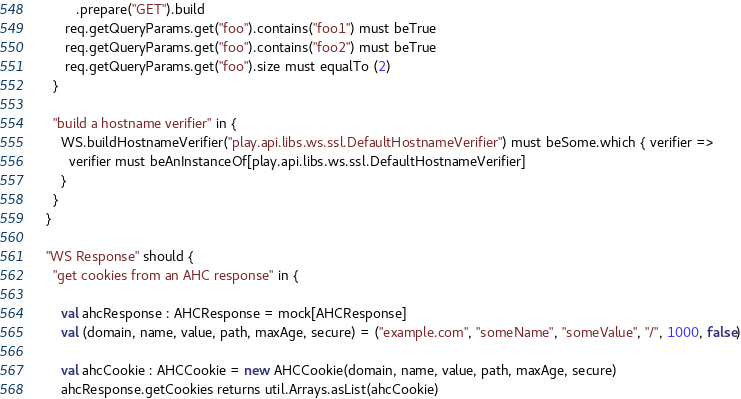<code> <loc_0><loc_0><loc_500><loc_500><_Scala_>          .prepare("GET").build
       req.getQueryParams.get("foo").contains("foo1") must beTrue
       req.getQueryParams.get("foo").contains("foo2") must beTrue
       req.getQueryParams.get("foo").size must equalTo (2)
    }

    "build a hostname verifier" in {
      WS.buildHostnameVerifier("play.api.libs.ws.ssl.DefaultHostnameVerifier") must beSome.which { verifier =>
        verifier must beAnInstanceOf[play.api.libs.ws.ssl.DefaultHostnameVerifier]
      }
    }
  }

  "WS Response" should {
    "get cookies from an AHC response" in {

      val ahcResponse : AHCResponse = mock[AHCResponse]
      val (domain, name, value, path, maxAge, secure) = ("example.com", "someName", "someValue", "/", 1000, false)

      val ahcCookie : AHCCookie = new AHCCookie(domain, name, value, path, maxAge, secure)
      ahcResponse.getCookies returns util.Arrays.asList(ahcCookie)
</code> 